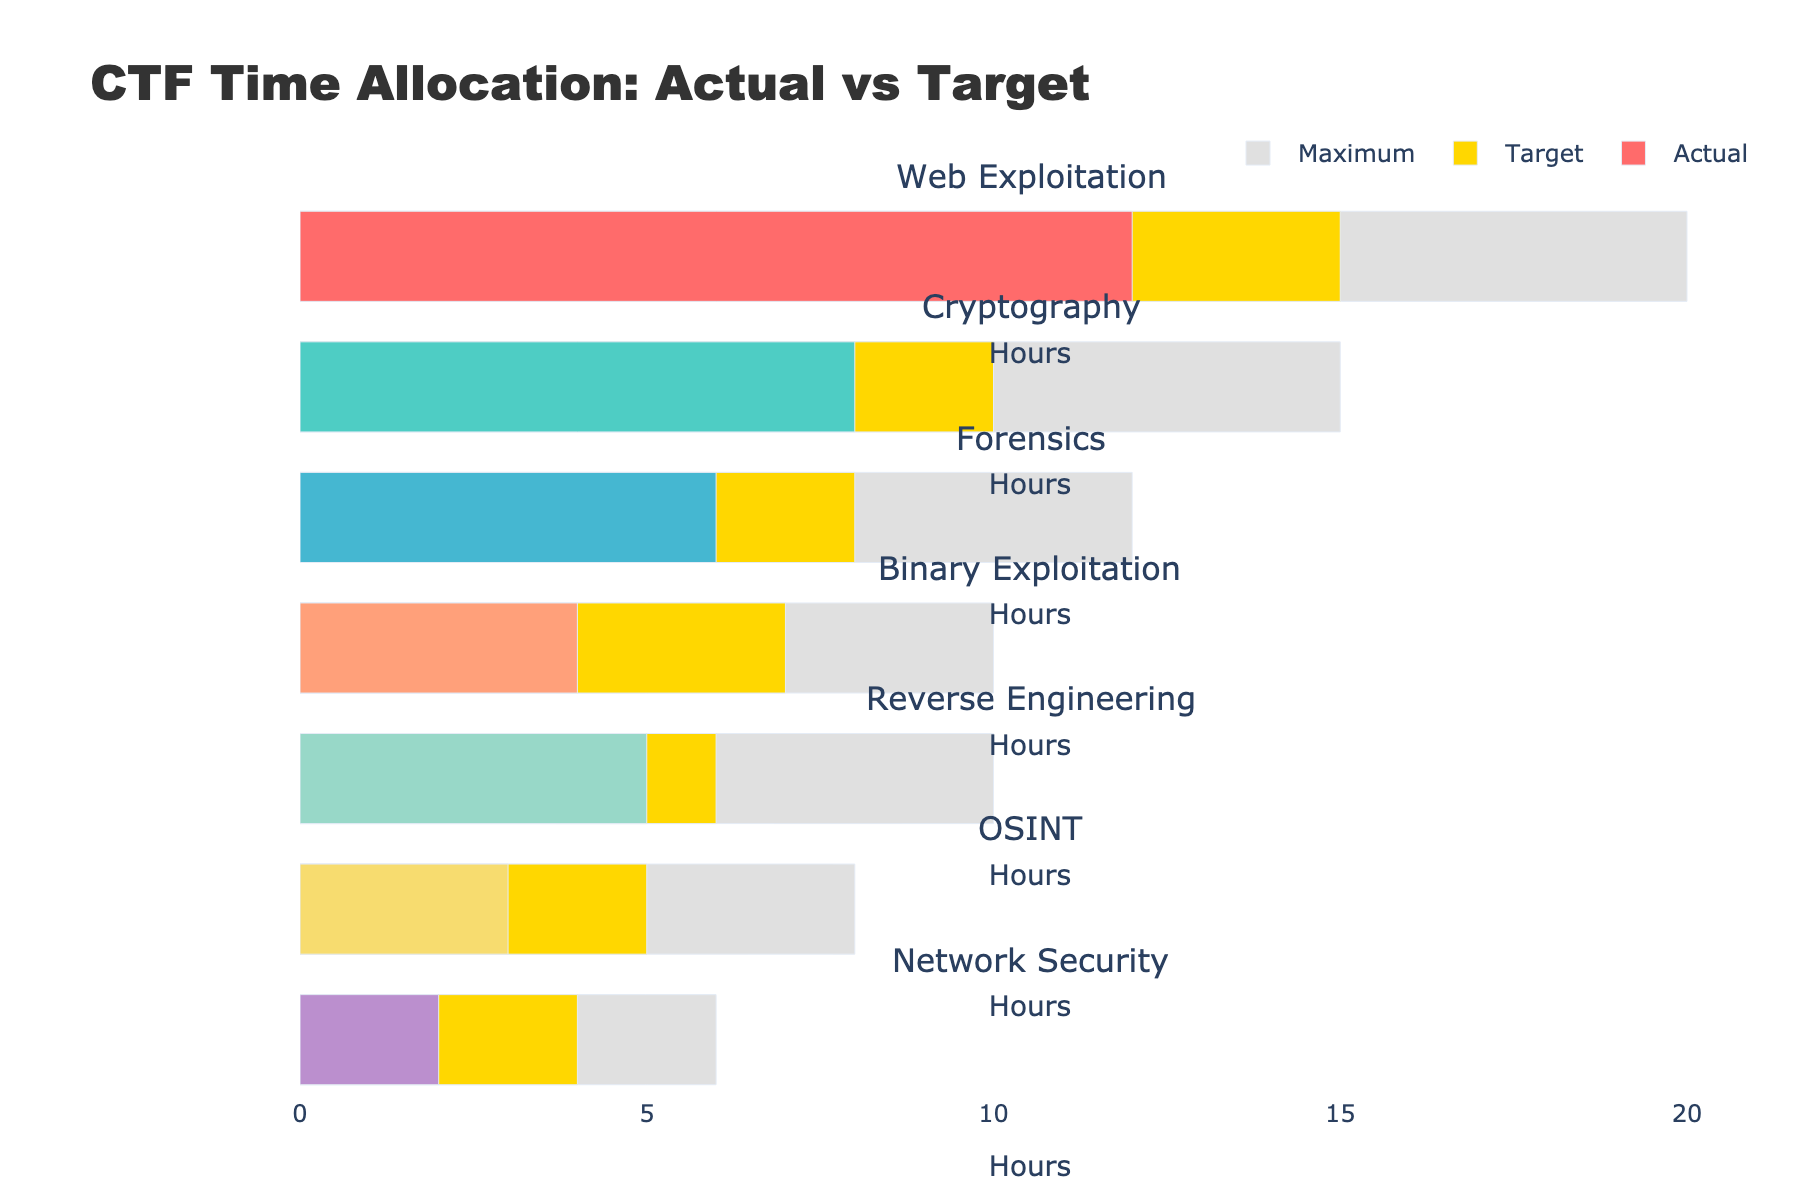What is the title of the bullet chart? The title can be found at the top of the chart, and it specifies the context of the data being visualized. In this chart, it reads "CTF Time Allocation: Actual vs Target".
Answer: CTF Time Allocation: Actual vs Target How many categories are displayed in the chart? By counting the unique category labels on the y-axis, we can determine the number of categories. There are 7 categories listed vertically.
Answer: 7 Which category has the highest target time? To answer this, compare the lengths of the yellow bars representing the target times for each category. The "Web Exploitation" category has the longest yellow bar.
Answer: Web Exploitation What is the difference between the actual and target times for the Forensics category? The actual time for Forensics is 6 hours, and the target time is 8 hours. The difference is calculated as 8 - 6 = 2 hours.
Answer: 2 hours What is the sum of the maximum times for all categories? Add the maximum times for each category: 20 + 15 + 12 + 10 + 10 + 8 + 6. The total is 81 hours.
Answer: 81 hours In which category is the actual time closest to the target time? Find the category where the smallest difference between the actual and target times occurs. For "Reverse Engineering", the target is 6 hours and the actual is 5 hours, so the difference is 1 hour, which is the smallest among all categories.
Answer: Reverse Engineering Which two categories have the same maximum time, and what is it? Identify categories with bars of equal length representing maximum time. Both "Binary Exploitation" and "Reverse Engineering" have maximum times of 10 hours.
Answer: Binary Exploitation and Reverse Engineering, 10 hours What is the average actual time spent across all categories? To calculate the average, sum up the actual times (12 + 8 + 6 + 4 + 5 + 3 + 2) = 40 and then divide by the number of categories, which is 7. So, the average is 40/7 ≈ 5.71 hours.
Answer: 5.71 hours Which category has the largest gap between the actual and maximum time? The gap is the difference between the maximum and actual times. For "Network Security", the maximum is 6 hours and actual is 2 hours, the gap is 4 hours, which is the largest.
Answer: Network Security Which category has the lowest actual time, and what is that time? By comparing the lengths of the colored bars representing the actual times, we see that "Network Security" has the shortest bar at 2 hours.
Answer: Network Security, 2 hours 